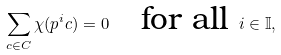<formula> <loc_0><loc_0><loc_500><loc_500>\sum _ { c \in C } \chi ( p ^ { i } c ) = 0 \quad \text {for all } i \in \mathbb { I } ,</formula> 